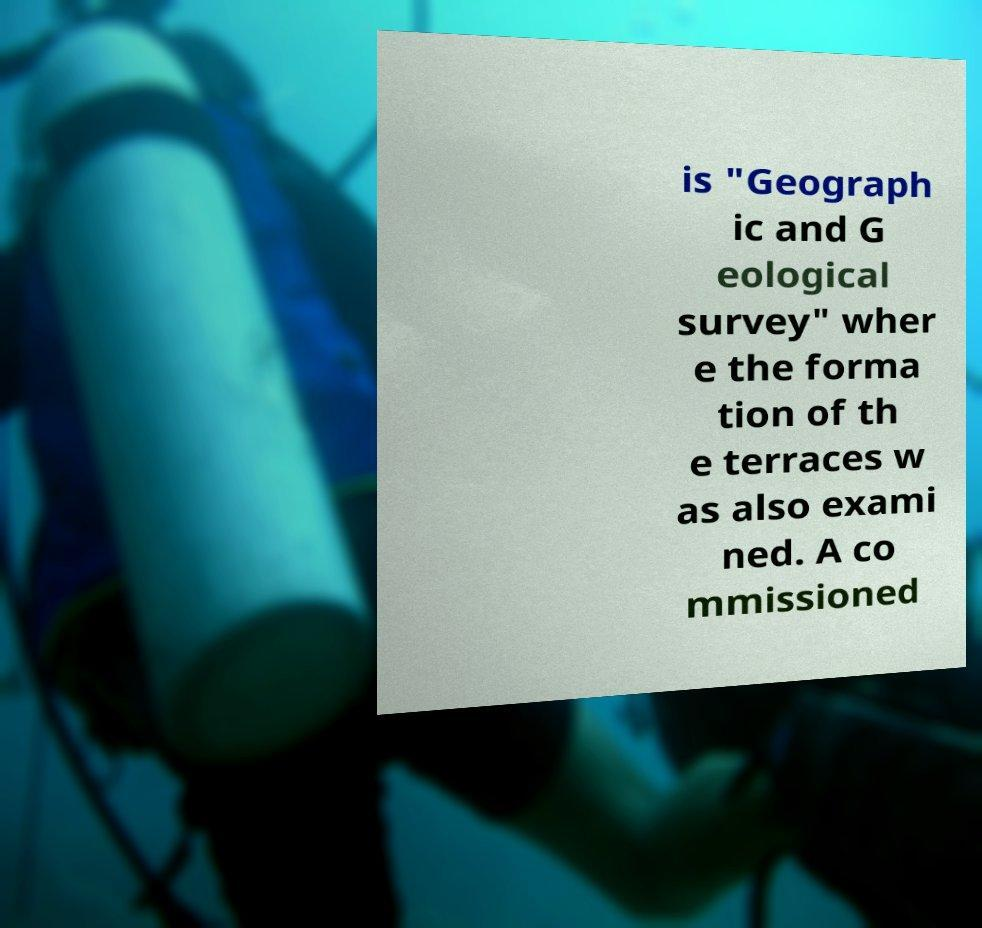What messages or text are displayed in this image? I need them in a readable, typed format. is "Geograph ic and G eological survey" wher e the forma tion of th e terraces w as also exami ned. A co mmissioned 